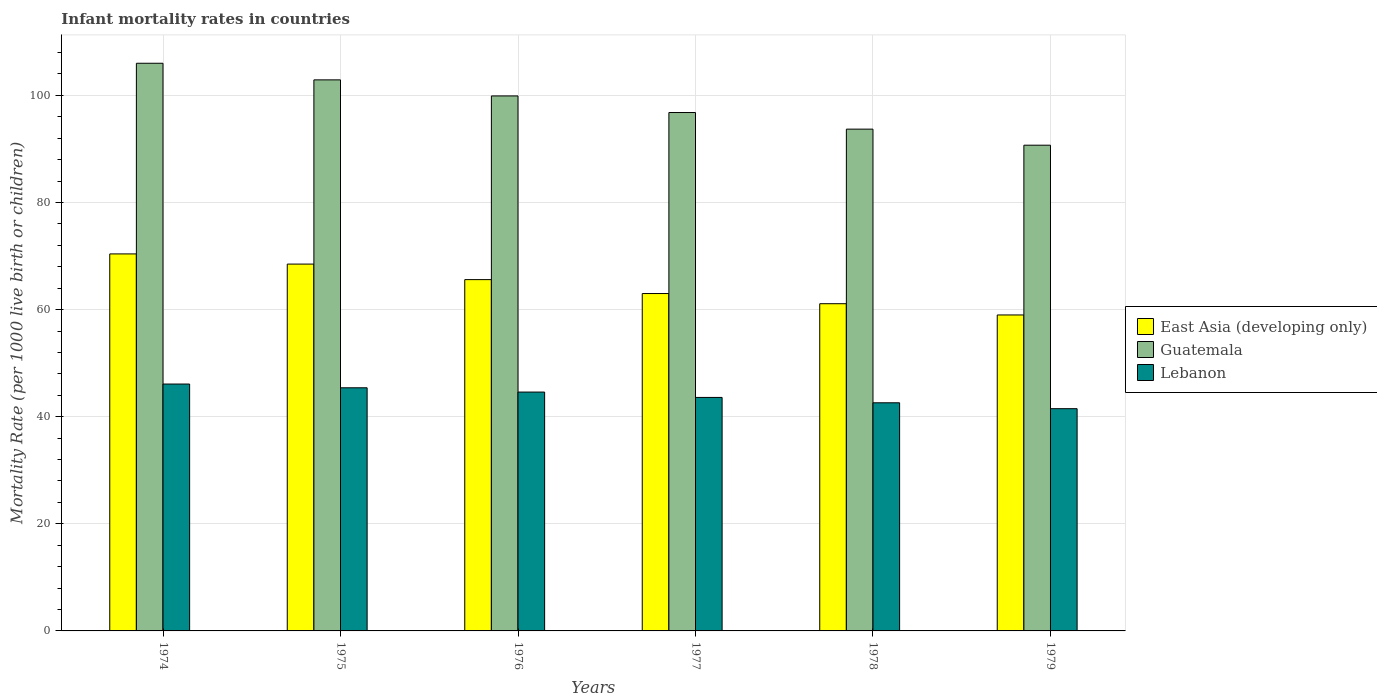What is the label of the 1st group of bars from the left?
Give a very brief answer. 1974. What is the infant mortality rate in Guatemala in 1977?
Provide a succinct answer. 96.8. Across all years, what is the maximum infant mortality rate in Guatemala?
Your response must be concise. 106. Across all years, what is the minimum infant mortality rate in Lebanon?
Your answer should be compact. 41.5. In which year was the infant mortality rate in Lebanon maximum?
Ensure brevity in your answer.  1974. In which year was the infant mortality rate in East Asia (developing only) minimum?
Make the answer very short. 1979. What is the total infant mortality rate in East Asia (developing only) in the graph?
Keep it short and to the point. 387.6. What is the difference between the infant mortality rate in East Asia (developing only) in 1974 and that in 1979?
Your answer should be very brief. 11.4. What is the difference between the infant mortality rate in Lebanon in 1976 and the infant mortality rate in Guatemala in 1978?
Make the answer very short. -49.1. What is the average infant mortality rate in Lebanon per year?
Provide a succinct answer. 43.97. In the year 1977, what is the difference between the infant mortality rate in East Asia (developing only) and infant mortality rate in Lebanon?
Provide a short and direct response. 19.4. In how many years, is the infant mortality rate in Lebanon greater than 104?
Make the answer very short. 0. What is the ratio of the infant mortality rate in East Asia (developing only) in 1976 to that in 1978?
Your answer should be very brief. 1.07. Is the difference between the infant mortality rate in East Asia (developing only) in 1974 and 1977 greater than the difference between the infant mortality rate in Lebanon in 1974 and 1977?
Keep it short and to the point. Yes. What is the difference between the highest and the second highest infant mortality rate in Lebanon?
Provide a succinct answer. 0.7. What is the difference between the highest and the lowest infant mortality rate in East Asia (developing only)?
Offer a very short reply. 11.4. What does the 2nd bar from the left in 1977 represents?
Your answer should be compact. Guatemala. What does the 1st bar from the right in 1978 represents?
Offer a terse response. Lebanon. Is it the case that in every year, the sum of the infant mortality rate in East Asia (developing only) and infant mortality rate in Guatemala is greater than the infant mortality rate in Lebanon?
Your response must be concise. Yes. Are all the bars in the graph horizontal?
Keep it short and to the point. No. What is the difference between two consecutive major ticks on the Y-axis?
Provide a succinct answer. 20. Does the graph contain any zero values?
Your response must be concise. No. Where does the legend appear in the graph?
Ensure brevity in your answer.  Center right. How are the legend labels stacked?
Make the answer very short. Vertical. What is the title of the graph?
Ensure brevity in your answer.  Infant mortality rates in countries. What is the label or title of the X-axis?
Your answer should be compact. Years. What is the label or title of the Y-axis?
Offer a very short reply. Mortality Rate (per 1000 live birth or children). What is the Mortality Rate (per 1000 live birth or children) in East Asia (developing only) in 1974?
Your response must be concise. 70.4. What is the Mortality Rate (per 1000 live birth or children) in Guatemala in 1974?
Offer a very short reply. 106. What is the Mortality Rate (per 1000 live birth or children) of Lebanon in 1974?
Keep it short and to the point. 46.1. What is the Mortality Rate (per 1000 live birth or children) of East Asia (developing only) in 1975?
Offer a very short reply. 68.5. What is the Mortality Rate (per 1000 live birth or children) in Guatemala in 1975?
Provide a succinct answer. 102.9. What is the Mortality Rate (per 1000 live birth or children) in Lebanon in 1975?
Your answer should be very brief. 45.4. What is the Mortality Rate (per 1000 live birth or children) of East Asia (developing only) in 1976?
Your answer should be compact. 65.6. What is the Mortality Rate (per 1000 live birth or children) in Guatemala in 1976?
Provide a short and direct response. 99.9. What is the Mortality Rate (per 1000 live birth or children) in Lebanon in 1976?
Make the answer very short. 44.6. What is the Mortality Rate (per 1000 live birth or children) in Guatemala in 1977?
Your answer should be compact. 96.8. What is the Mortality Rate (per 1000 live birth or children) in Lebanon in 1977?
Your response must be concise. 43.6. What is the Mortality Rate (per 1000 live birth or children) in East Asia (developing only) in 1978?
Provide a succinct answer. 61.1. What is the Mortality Rate (per 1000 live birth or children) in Guatemala in 1978?
Your response must be concise. 93.7. What is the Mortality Rate (per 1000 live birth or children) in Lebanon in 1978?
Your response must be concise. 42.6. What is the Mortality Rate (per 1000 live birth or children) of East Asia (developing only) in 1979?
Give a very brief answer. 59. What is the Mortality Rate (per 1000 live birth or children) of Guatemala in 1979?
Your response must be concise. 90.7. What is the Mortality Rate (per 1000 live birth or children) in Lebanon in 1979?
Give a very brief answer. 41.5. Across all years, what is the maximum Mortality Rate (per 1000 live birth or children) in East Asia (developing only)?
Make the answer very short. 70.4. Across all years, what is the maximum Mortality Rate (per 1000 live birth or children) in Guatemala?
Offer a very short reply. 106. Across all years, what is the maximum Mortality Rate (per 1000 live birth or children) of Lebanon?
Your response must be concise. 46.1. Across all years, what is the minimum Mortality Rate (per 1000 live birth or children) of East Asia (developing only)?
Provide a short and direct response. 59. Across all years, what is the minimum Mortality Rate (per 1000 live birth or children) of Guatemala?
Provide a short and direct response. 90.7. Across all years, what is the minimum Mortality Rate (per 1000 live birth or children) in Lebanon?
Your answer should be very brief. 41.5. What is the total Mortality Rate (per 1000 live birth or children) in East Asia (developing only) in the graph?
Offer a very short reply. 387.6. What is the total Mortality Rate (per 1000 live birth or children) in Guatemala in the graph?
Make the answer very short. 590. What is the total Mortality Rate (per 1000 live birth or children) in Lebanon in the graph?
Provide a short and direct response. 263.8. What is the difference between the Mortality Rate (per 1000 live birth or children) in East Asia (developing only) in 1974 and that in 1975?
Give a very brief answer. 1.9. What is the difference between the Mortality Rate (per 1000 live birth or children) of Guatemala in 1974 and that in 1975?
Your answer should be compact. 3.1. What is the difference between the Mortality Rate (per 1000 live birth or children) in Guatemala in 1974 and that in 1976?
Provide a short and direct response. 6.1. What is the difference between the Mortality Rate (per 1000 live birth or children) in East Asia (developing only) in 1974 and that in 1977?
Provide a short and direct response. 7.4. What is the difference between the Mortality Rate (per 1000 live birth or children) in Guatemala in 1974 and that in 1977?
Provide a short and direct response. 9.2. What is the difference between the Mortality Rate (per 1000 live birth or children) of Lebanon in 1974 and that in 1977?
Provide a succinct answer. 2.5. What is the difference between the Mortality Rate (per 1000 live birth or children) in Guatemala in 1974 and that in 1978?
Provide a short and direct response. 12.3. What is the difference between the Mortality Rate (per 1000 live birth or children) of Lebanon in 1974 and that in 1978?
Ensure brevity in your answer.  3.5. What is the difference between the Mortality Rate (per 1000 live birth or children) in East Asia (developing only) in 1974 and that in 1979?
Keep it short and to the point. 11.4. What is the difference between the Mortality Rate (per 1000 live birth or children) of Guatemala in 1974 and that in 1979?
Make the answer very short. 15.3. What is the difference between the Mortality Rate (per 1000 live birth or children) of Guatemala in 1975 and that in 1976?
Offer a very short reply. 3. What is the difference between the Mortality Rate (per 1000 live birth or children) in East Asia (developing only) in 1975 and that in 1978?
Provide a succinct answer. 7.4. What is the difference between the Mortality Rate (per 1000 live birth or children) in Guatemala in 1975 and that in 1978?
Keep it short and to the point. 9.2. What is the difference between the Mortality Rate (per 1000 live birth or children) in Lebanon in 1975 and that in 1978?
Your answer should be compact. 2.8. What is the difference between the Mortality Rate (per 1000 live birth or children) of East Asia (developing only) in 1975 and that in 1979?
Your response must be concise. 9.5. What is the difference between the Mortality Rate (per 1000 live birth or children) of Lebanon in 1975 and that in 1979?
Provide a succinct answer. 3.9. What is the difference between the Mortality Rate (per 1000 live birth or children) in East Asia (developing only) in 1976 and that in 1978?
Offer a terse response. 4.5. What is the difference between the Mortality Rate (per 1000 live birth or children) in Guatemala in 1976 and that in 1978?
Your response must be concise. 6.2. What is the difference between the Mortality Rate (per 1000 live birth or children) of Lebanon in 1976 and that in 1978?
Your answer should be compact. 2. What is the difference between the Mortality Rate (per 1000 live birth or children) in Guatemala in 1976 and that in 1979?
Provide a short and direct response. 9.2. What is the difference between the Mortality Rate (per 1000 live birth or children) of Guatemala in 1977 and that in 1978?
Make the answer very short. 3.1. What is the difference between the Mortality Rate (per 1000 live birth or children) in Lebanon in 1977 and that in 1979?
Give a very brief answer. 2.1. What is the difference between the Mortality Rate (per 1000 live birth or children) in East Asia (developing only) in 1978 and that in 1979?
Your answer should be very brief. 2.1. What is the difference between the Mortality Rate (per 1000 live birth or children) in East Asia (developing only) in 1974 and the Mortality Rate (per 1000 live birth or children) in Guatemala in 1975?
Provide a short and direct response. -32.5. What is the difference between the Mortality Rate (per 1000 live birth or children) in Guatemala in 1974 and the Mortality Rate (per 1000 live birth or children) in Lebanon in 1975?
Provide a short and direct response. 60.6. What is the difference between the Mortality Rate (per 1000 live birth or children) of East Asia (developing only) in 1974 and the Mortality Rate (per 1000 live birth or children) of Guatemala in 1976?
Keep it short and to the point. -29.5. What is the difference between the Mortality Rate (per 1000 live birth or children) in East Asia (developing only) in 1974 and the Mortality Rate (per 1000 live birth or children) in Lebanon in 1976?
Your answer should be very brief. 25.8. What is the difference between the Mortality Rate (per 1000 live birth or children) of Guatemala in 1974 and the Mortality Rate (per 1000 live birth or children) of Lebanon in 1976?
Your response must be concise. 61.4. What is the difference between the Mortality Rate (per 1000 live birth or children) in East Asia (developing only) in 1974 and the Mortality Rate (per 1000 live birth or children) in Guatemala in 1977?
Offer a terse response. -26.4. What is the difference between the Mortality Rate (per 1000 live birth or children) of East Asia (developing only) in 1974 and the Mortality Rate (per 1000 live birth or children) of Lebanon in 1977?
Make the answer very short. 26.8. What is the difference between the Mortality Rate (per 1000 live birth or children) of Guatemala in 1974 and the Mortality Rate (per 1000 live birth or children) of Lebanon in 1977?
Provide a succinct answer. 62.4. What is the difference between the Mortality Rate (per 1000 live birth or children) in East Asia (developing only) in 1974 and the Mortality Rate (per 1000 live birth or children) in Guatemala in 1978?
Provide a succinct answer. -23.3. What is the difference between the Mortality Rate (per 1000 live birth or children) in East Asia (developing only) in 1974 and the Mortality Rate (per 1000 live birth or children) in Lebanon in 1978?
Your answer should be very brief. 27.8. What is the difference between the Mortality Rate (per 1000 live birth or children) of Guatemala in 1974 and the Mortality Rate (per 1000 live birth or children) of Lebanon in 1978?
Ensure brevity in your answer.  63.4. What is the difference between the Mortality Rate (per 1000 live birth or children) of East Asia (developing only) in 1974 and the Mortality Rate (per 1000 live birth or children) of Guatemala in 1979?
Offer a terse response. -20.3. What is the difference between the Mortality Rate (per 1000 live birth or children) in East Asia (developing only) in 1974 and the Mortality Rate (per 1000 live birth or children) in Lebanon in 1979?
Provide a short and direct response. 28.9. What is the difference between the Mortality Rate (per 1000 live birth or children) of Guatemala in 1974 and the Mortality Rate (per 1000 live birth or children) of Lebanon in 1979?
Give a very brief answer. 64.5. What is the difference between the Mortality Rate (per 1000 live birth or children) in East Asia (developing only) in 1975 and the Mortality Rate (per 1000 live birth or children) in Guatemala in 1976?
Your answer should be compact. -31.4. What is the difference between the Mortality Rate (per 1000 live birth or children) of East Asia (developing only) in 1975 and the Mortality Rate (per 1000 live birth or children) of Lebanon in 1976?
Give a very brief answer. 23.9. What is the difference between the Mortality Rate (per 1000 live birth or children) in Guatemala in 1975 and the Mortality Rate (per 1000 live birth or children) in Lebanon in 1976?
Make the answer very short. 58.3. What is the difference between the Mortality Rate (per 1000 live birth or children) in East Asia (developing only) in 1975 and the Mortality Rate (per 1000 live birth or children) in Guatemala in 1977?
Your answer should be compact. -28.3. What is the difference between the Mortality Rate (per 1000 live birth or children) of East Asia (developing only) in 1975 and the Mortality Rate (per 1000 live birth or children) of Lebanon in 1977?
Make the answer very short. 24.9. What is the difference between the Mortality Rate (per 1000 live birth or children) of Guatemala in 1975 and the Mortality Rate (per 1000 live birth or children) of Lebanon in 1977?
Provide a succinct answer. 59.3. What is the difference between the Mortality Rate (per 1000 live birth or children) of East Asia (developing only) in 1975 and the Mortality Rate (per 1000 live birth or children) of Guatemala in 1978?
Your response must be concise. -25.2. What is the difference between the Mortality Rate (per 1000 live birth or children) in East Asia (developing only) in 1975 and the Mortality Rate (per 1000 live birth or children) in Lebanon in 1978?
Your response must be concise. 25.9. What is the difference between the Mortality Rate (per 1000 live birth or children) in Guatemala in 1975 and the Mortality Rate (per 1000 live birth or children) in Lebanon in 1978?
Give a very brief answer. 60.3. What is the difference between the Mortality Rate (per 1000 live birth or children) in East Asia (developing only) in 1975 and the Mortality Rate (per 1000 live birth or children) in Guatemala in 1979?
Your answer should be very brief. -22.2. What is the difference between the Mortality Rate (per 1000 live birth or children) of East Asia (developing only) in 1975 and the Mortality Rate (per 1000 live birth or children) of Lebanon in 1979?
Your answer should be very brief. 27. What is the difference between the Mortality Rate (per 1000 live birth or children) in Guatemala in 1975 and the Mortality Rate (per 1000 live birth or children) in Lebanon in 1979?
Your response must be concise. 61.4. What is the difference between the Mortality Rate (per 1000 live birth or children) in East Asia (developing only) in 1976 and the Mortality Rate (per 1000 live birth or children) in Guatemala in 1977?
Offer a terse response. -31.2. What is the difference between the Mortality Rate (per 1000 live birth or children) of Guatemala in 1976 and the Mortality Rate (per 1000 live birth or children) of Lebanon in 1977?
Ensure brevity in your answer.  56.3. What is the difference between the Mortality Rate (per 1000 live birth or children) in East Asia (developing only) in 1976 and the Mortality Rate (per 1000 live birth or children) in Guatemala in 1978?
Your answer should be compact. -28.1. What is the difference between the Mortality Rate (per 1000 live birth or children) in Guatemala in 1976 and the Mortality Rate (per 1000 live birth or children) in Lebanon in 1978?
Provide a short and direct response. 57.3. What is the difference between the Mortality Rate (per 1000 live birth or children) of East Asia (developing only) in 1976 and the Mortality Rate (per 1000 live birth or children) of Guatemala in 1979?
Your response must be concise. -25.1. What is the difference between the Mortality Rate (per 1000 live birth or children) in East Asia (developing only) in 1976 and the Mortality Rate (per 1000 live birth or children) in Lebanon in 1979?
Your answer should be very brief. 24.1. What is the difference between the Mortality Rate (per 1000 live birth or children) of Guatemala in 1976 and the Mortality Rate (per 1000 live birth or children) of Lebanon in 1979?
Keep it short and to the point. 58.4. What is the difference between the Mortality Rate (per 1000 live birth or children) in East Asia (developing only) in 1977 and the Mortality Rate (per 1000 live birth or children) in Guatemala in 1978?
Ensure brevity in your answer.  -30.7. What is the difference between the Mortality Rate (per 1000 live birth or children) in East Asia (developing only) in 1977 and the Mortality Rate (per 1000 live birth or children) in Lebanon in 1978?
Your answer should be compact. 20.4. What is the difference between the Mortality Rate (per 1000 live birth or children) in Guatemala in 1977 and the Mortality Rate (per 1000 live birth or children) in Lebanon in 1978?
Your response must be concise. 54.2. What is the difference between the Mortality Rate (per 1000 live birth or children) of East Asia (developing only) in 1977 and the Mortality Rate (per 1000 live birth or children) of Guatemala in 1979?
Ensure brevity in your answer.  -27.7. What is the difference between the Mortality Rate (per 1000 live birth or children) of East Asia (developing only) in 1977 and the Mortality Rate (per 1000 live birth or children) of Lebanon in 1979?
Offer a terse response. 21.5. What is the difference between the Mortality Rate (per 1000 live birth or children) in Guatemala in 1977 and the Mortality Rate (per 1000 live birth or children) in Lebanon in 1979?
Your response must be concise. 55.3. What is the difference between the Mortality Rate (per 1000 live birth or children) in East Asia (developing only) in 1978 and the Mortality Rate (per 1000 live birth or children) in Guatemala in 1979?
Keep it short and to the point. -29.6. What is the difference between the Mortality Rate (per 1000 live birth or children) in East Asia (developing only) in 1978 and the Mortality Rate (per 1000 live birth or children) in Lebanon in 1979?
Offer a terse response. 19.6. What is the difference between the Mortality Rate (per 1000 live birth or children) in Guatemala in 1978 and the Mortality Rate (per 1000 live birth or children) in Lebanon in 1979?
Offer a very short reply. 52.2. What is the average Mortality Rate (per 1000 live birth or children) of East Asia (developing only) per year?
Ensure brevity in your answer.  64.6. What is the average Mortality Rate (per 1000 live birth or children) in Guatemala per year?
Ensure brevity in your answer.  98.33. What is the average Mortality Rate (per 1000 live birth or children) of Lebanon per year?
Offer a terse response. 43.97. In the year 1974, what is the difference between the Mortality Rate (per 1000 live birth or children) in East Asia (developing only) and Mortality Rate (per 1000 live birth or children) in Guatemala?
Offer a terse response. -35.6. In the year 1974, what is the difference between the Mortality Rate (per 1000 live birth or children) in East Asia (developing only) and Mortality Rate (per 1000 live birth or children) in Lebanon?
Offer a terse response. 24.3. In the year 1974, what is the difference between the Mortality Rate (per 1000 live birth or children) of Guatemala and Mortality Rate (per 1000 live birth or children) of Lebanon?
Offer a very short reply. 59.9. In the year 1975, what is the difference between the Mortality Rate (per 1000 live birth or children) of East Asia (developing only) and Mortality Rate (per 1000 live birth or children) of Guatemala?
Keep it short and to the point. -34.4. In the year 1975, what is the difference between the Mortality Rate (per 1000 live birth or children) of East Asia (developing only) and Mortality Rate (per 1000 live birth or children) of Lebanon?
Your answer should be compact. 23.1. In the year 1975, what is the difference between the Mortality Rate (per 1000 live birth or children) in Guatemala and Mortality Rate (per 1000 live birth or children) in Lebanon?
Make the answer very short. 57.5. In the year 1976, what is the difference between the Mortality Rate (per 1000 live birth or children) of East Asia (developing only) and Mortality Rate (per 1000 live birth or children) of Guatemala?
Provide a succinct answer. -34.3. In the year 1976, what is the difference between the Mortality Rate (per 1000 live birth or children) of East Asia (developing only) and Mortality Rate (per 1000 live birth or children) of Lebanon?
Provide a succinct answer. 21. In the year 1976, what is the difference between the Mortality Rate (per 1000 live birth or children) of Guatemala and Mortality Rate (per 1000 live birth or children) of Lebanon?
Keep it short and to the point. 55.3. In the year 1977, what is the difference between the Mortality Rate (per 1000 live birth or children) of East Asia (developing only) and Mortality Rate (per 1000 live birth or children) of Guatemala?
Your response must be concise. -33.8. In the year 1977, what is the difference between the Mortality Rate (per 1000 live birth or children) of Guatemala and Mortality Rate (per 1000 live birth or children) of Lebanon?
Ensure brevity in your answer.  53.2. In the year 1978, what is the difference between the Mortality Rate (per 1000 live birth or children) of East Asia (developing only) and Mortality Rate (per 1000 live birth or children) of Guatemala?
Provide a short and direct response. -32.6. In the year 1978, what is the difference between the Mortality Rate (per 1000 live birth or children) in Guatemala and Mortality Rate (per 1000 live birth or children) in Lebanon?
Your response must be concise. 51.1. In the year 1979, what is the difference between the Mortality Rate (per 1000 live birth or children) in East Asia (developing only) and Mortality Rate (per 1000 live birth or children) in Guatemala?
Make the answer very short. -31.7. In the year 1979, what is the difference between the Mortality Rate (per 1000 live birth or children) in East Asia (developing only) and Mortality Rate (per 1000 live birth or children) in Lebanon?
Your answer should be compact. 17.5. In the year 1979, what is the difference between the Mortality Rate (per 1000 live birth or children) in Guatemala and Mortality Rate (per 1000 live birth or children) in Lebanon?
Your answer should be very brief. 49.2. What is the ratio of the Mortality Rate (per 1000 live birth or children) of East Asia (developing only) in 1974 to that in 1975?
Your answer should be compact. 1.03. What is the ratio of the Mortality Rate (per 1000 live birth or children) in Guatemala in 1974 to that in 1975?
Provide a short and direct response. 1.03. What is the ratio of the Mortality Rate (per 1000 live birth or children) of Lebanon in 1974 to that in 1975?
Offer a terse response. 1.02. What is the ratio of the Mortality Rate (per 1000 live birth or children) in East Asia (developing only) in 1974 to that in 1976?
Give a very brief answer. 1.07. What is the ratio of the Mortality Rate (per 1000 live birth or children) of Guatemala in 1974 to that in 1976?
Give a very brief answer. 1.06. What is the ratio of the Mortality Rate (per 1000 live birth or children) of Lebanon in 1974 to that in 1976?
Offer a very short reply. 1.03. What is the ratio of the Mortality Rate (per 1000 live birth or children) in East Asia (developing only) in 1974 to that in 1977?
Your answer should be compact. 1.12. What is the ratio of the Mortality Rate (per 1000 live birth or children) of Guatemala in 1974 to that in 1977?
Your response must be concise. 1.09. What is the ratio of the Mortality Rate (per 1000 live birth or children) in Lebanon in 1974 to that in 1977?
Ensure brevity in your answer.  1.06. What is the ratio of the Mortality Rate (per 1000 live birth or children) in East Asia (developing only) in 1974 to that in 1978?
Provide a succinct answer. 1.15. What is the ratio of the Mortality Rate (per 1000 live birth or children) in Guatemala in 1974 to that in 1978?
Provide a succinct answer. 1.13. What is the ratio of the Mortality Rate (per 1000 live birth or children) of Lebanon in 1974 to that in 1978?
Your answer should be very brief. 1.08. What is the ratio of the Mortality Rate (per 1000 live birth or children) in East Asia (developing only) in 1974 to that in 1979?
Offer a terse response. 1.19. What is the ratio of the Mortality Rate (per 1000 live birth or children) in Guatemala in 1974 to that in 1979?
Your answer should be compact. 1.17. What is the ratio of the Mortality Rate (per 1000 live birth or children) in Lebanon in 1974 to that in 1979?
Offer a very short reply. 1.11. What is the ratio of the Mortality Rate (per 1000 live birth or children) in East Asia (developing only) in 1975 to that in 1976?
Make the answer very short. 1.04. What is the ratio of the Mortality Rate (per 1000 live birth or children) in Lebanon in 1975 to that in 1976?
Your answer should be compact. 1.02. What is the ratio of the Mortality Rate (per 1000 live birth or children) of East Asia (developing only) in 1975 to that in 1977?
Your answer should be very brief. 1.09. What is the ratio of the Mortality Rate (per 1000 live birth or children) in Guatemala in 1975 to that in 1977?
Make the answer very short. 1.06. What is the ratio of the Mortality Rate (per 1000 live birth or children) of Lebanon in 1975 to that in 1977?
Your response must be concise. 1.04. What is the ratio of the Mortality Rate (per 1000 live birth or children) in East Asia (developing only) in 1975 to that in 1978?
Your response must be concise. 1.12. What is the ratio of the Mortality Rate (per 1000 live birth or children) of Guatemala in 1975 to that in 1978?
Ensure brevity in your answer.  1.1. What is the ratio of the Mortality Rate (per 1000 live birth or children) in Lebanon in 1975 to that in 1978?
Make the answer very short. 1.07. What is the ratio of the Mortality Rate (per 1000 live birth or children) of East Asia (developing only) in 1975 to that in 1979?
Make the answer very short. 1.16. What is the ratio of the Mortality Rate (per 1000 live birth or children) in Guatemala in 1975 to that in 1979?
Provide a short and direct response. 1.13. What is the ratio of the Mortality Rate (per 1000 live birth or children) in Lebanon in 1975 to that in 1979?
Provide a short and direct response. 1.09. What is the ratio of the Mortality Rate (per 1000 live birth or children) of East Asia (developing only) in 1976 to that in 1977?
Ensure brevity in your answer.  1.04. What is the ratio of the Mortality Rate (per 1000 live birth or children) in Guatemala in 1976 to that in 1977?
Provide a succinct answer. 1.03. What is the ratio of the Mortality Rate (per 1000 live birth or children) of Lebanon in 1976 to that in 1977?
Your answer should be very brief. 1.02. What is the ratio of the Mortality Rate (per 1000 live birth or children) in East Asia (developing only) in 1976 to that in 1978?
Provide a short and direct response. 1.07. What is the ratio of the Mortality Rate (per 1000 live birth or children) in Guatemala in 1976 to that in 1978?
Make the answer very short. 1.07. What is the ratio of the Mortality Rate (per 1000 live birth or children) of Lebanon in 1976 to that in 1978?
Ensure brevity in your answer.  1.05. What is the ratio of the Mortality Rate (per 1000 live birth or children) in East Asia (developing only) in 1976 to that in 1979?
Ensure brevity in your answer.  1.11. What is the ratio of the Mortality Rate (per 1000 live birth or children) of Guatemala in 1976 to that in 1979?
Offer a very short reply. 1.1. What is the ratio of the Mortality Rate (per 1000 live birth or children) of Lebanon in 1976 to that in 1979?
Your response must be concise. 1.07. What is the ratio of the Mortality Rate (per 1000 live birth or children) in East Asia (developing only) in 1977 to that in 1978?
Your response must be concise. 1.03. What is the ratio of the Mortality Rate (per 1000 live birth or children) in Guatemala in 1977 to that in 1978?
Provide a short and direct response. 1.03. What is the ratio of the Mortality Rate (per 1000 live birth or children) of Lebanon in 1977 to that in 1978?
Provide a succinct answer. 1.02. What is the ratio of the Mortality Rate (per 1000 live birth or children) in East Asia (developing only) in 1977 to that in 1979?
Ensure brevity in your answer.  1.07. What is the ratio of the Mortality Rate (per 1000 live birth or children) of Guatemala in 1977 to that in 1979?
Ensure brevity in your answer.  1.07. What is the ratio of the Mortality Rate (per 1000 live birth or children) of Lebanon in 1977 to that in 1979?
Keep it short and to the point. 1.05. What is the ratio of the Mortality Rate (per 1000 live birth or children) of East Asia (developing only) in 1978 to that in 1979?
Provide a short and direct response. 1.04. What is the ratio of the Mortality Rate (per 1000 live birth or children) of Guatemala in 1978 to that in 1979?
Your response must be concise. 1.03. What is the ratio of the Mortality Rate (per 1000 live birth or children) in Lebanon in 1978 to that in 1979?
Offer a very short reply. 1.03. What is the difference between the highest and the second highest Mortality Rate (per 1000 live birth or children) in East Asia (developing only)?
Ensure brevity in your answer.  1.9. What is the difference between the highest and the second highest Mortality Rate (per 1000 live birth or children) of Guatemala?
Provide a succinct answer. 3.1. What is the difference between the highest and the lowest Mortality Rate (per 1000 live birth or children) of East Asia (developing only)?
Provide a succinct answer. 11.4. 